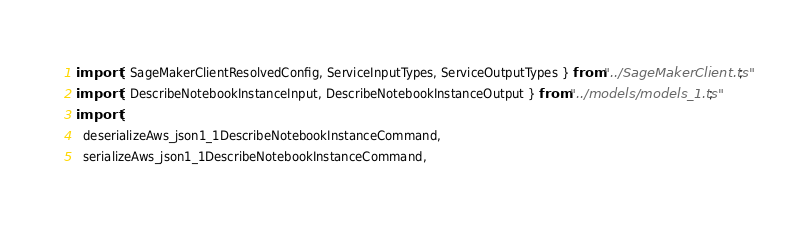Convert code to text. <code><loc_0><loc_0><loc_500><loc_500><_TypeScript_>import { SageMakerClientResolvedConfig, ServiceInputTypes, ServiceOutputTypes } from "../SageMakerClient.ts";
import { DescribeNotebookInstanceInput, DescribeNotebookInstanceOutput } from "../models/models_1.ts";
import {
  deserializeAws_json1_1DescribeNotebookInstanceCommand,
  serializeAws_json1_1DescribeNotebookInstanceCommand,</code> 